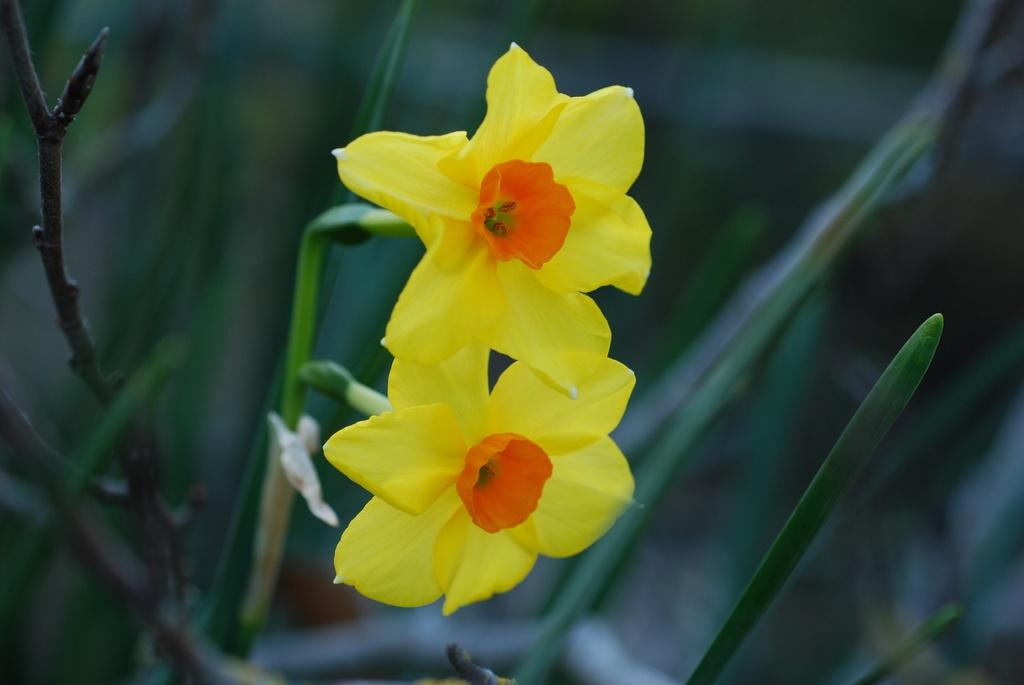What type of flowers can be seen in the image? There are two yellow flowers in the image. Where are the flowers located in the image? The flowers are in the center of the image. What type of joke is being told by the flowers in the image? There is no indication in the image that the flowers are telling a joke, as flowers do not have the ability to speak or tell jokes. 